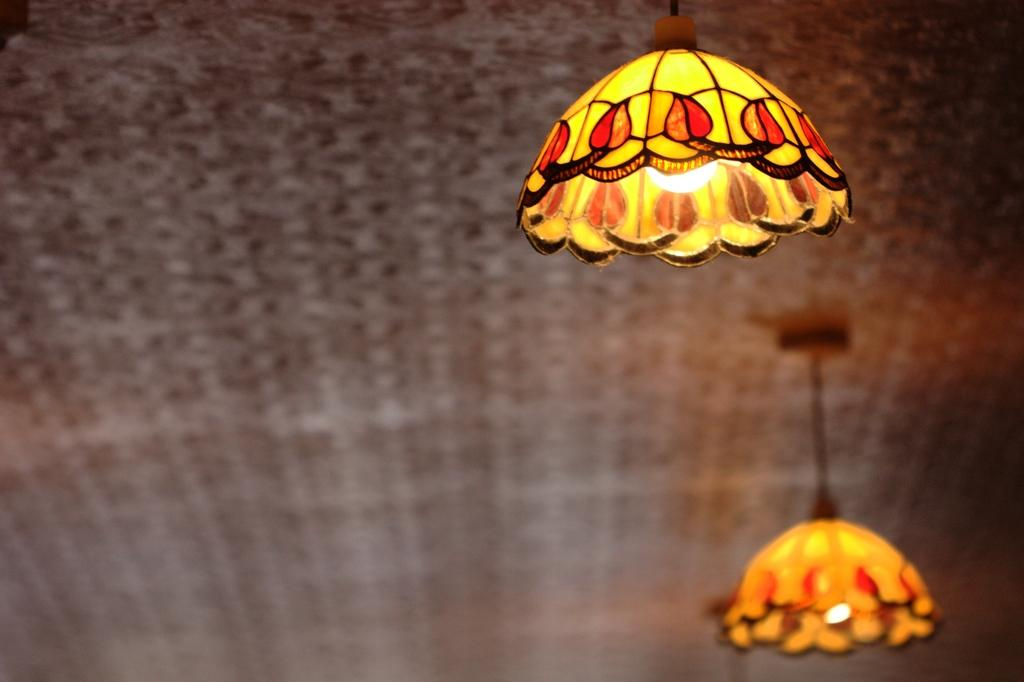How many lamps can be seen in the image? There are two lamps in the image. Where are the lamps located? The lamps are hanging from the ceiling. What can be observed about the lamps' appearance? There is a design on the lamps. How many cakes are being held up by the net in the image? There are no cakes or nets present in the image; it only features two lamps hanging from the ceiling. 